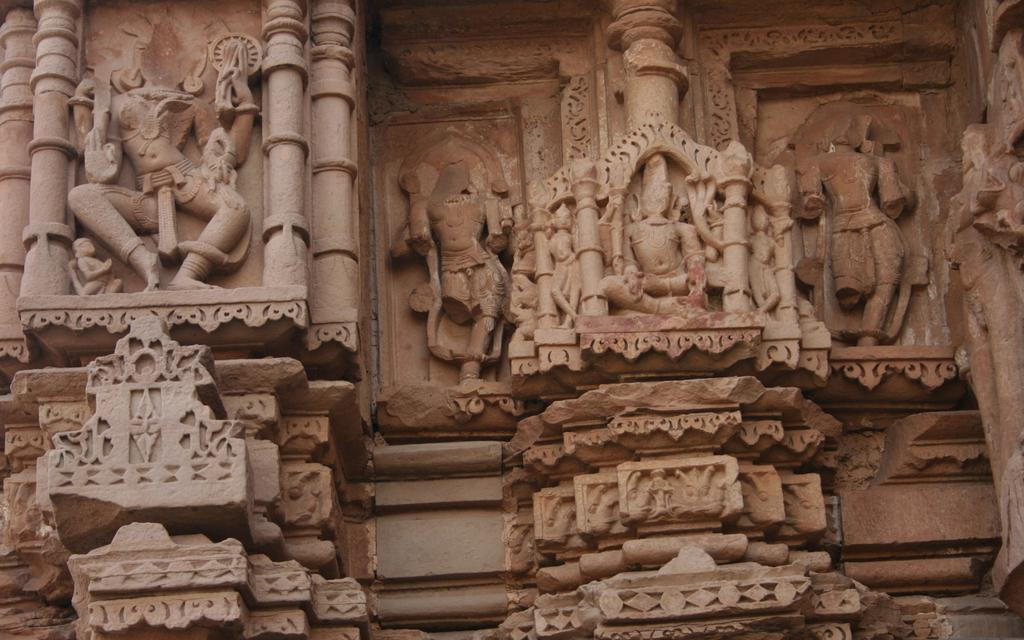What type of art or design can be seen in the image? The picture contains stone carving. Can you describe the material used in the carving? The material used in the carving is stone. What might be the purpose of the stone carving? The purpose of the stone carving could be decorative, commemorative, or symbolic. How many frogs are sitting on the desk in the image? There is no desk or frogs present in the image; it features a stone carving. 